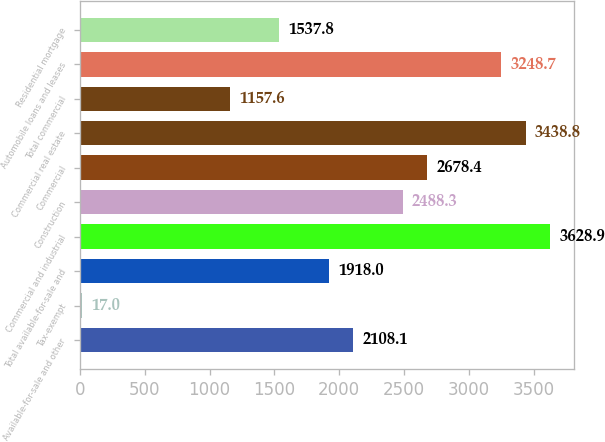Convert chart to OTSL. <chart><loc_0><loc_0><loc_500><loc_500><bar_chart><fcel>Available-for-sale and other<fcel>Tax-exempt<fcel>Total available-for-sale and<fcel>Commercial and industrial<fcel>Construction<fcel>Commercial<fcel>Commercial real estate<fcel>Total commercial<fcel>Automobile loans and leases<fcel>Residential mortgage<nl><fcel>2108.1<fcel>17<fcel>1918<fcel>3628.9<fcel>2488.3<fcel>2678.4<fcel>3438.8<fcel>1157.6<fcel>3248.7<fcel>1537.8<nl></chart> 